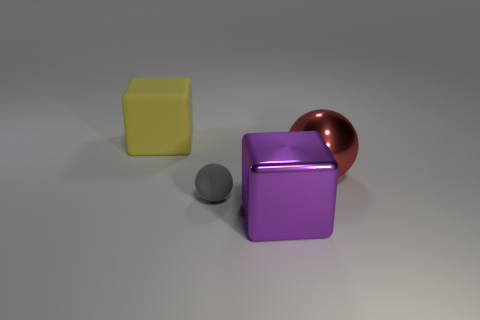Could you guess the materials of the objects? Indeed, the yellow and purple cubes exhibit a matte finish indicative of a plastic or matte painted metal, and the small grey sphere seems to be of a similar material but with a smoother surface. The big sphere atop the purple cube, however, has a reflective surface that suggests a metallic composition, possibly copper or a copper-like alloy. 